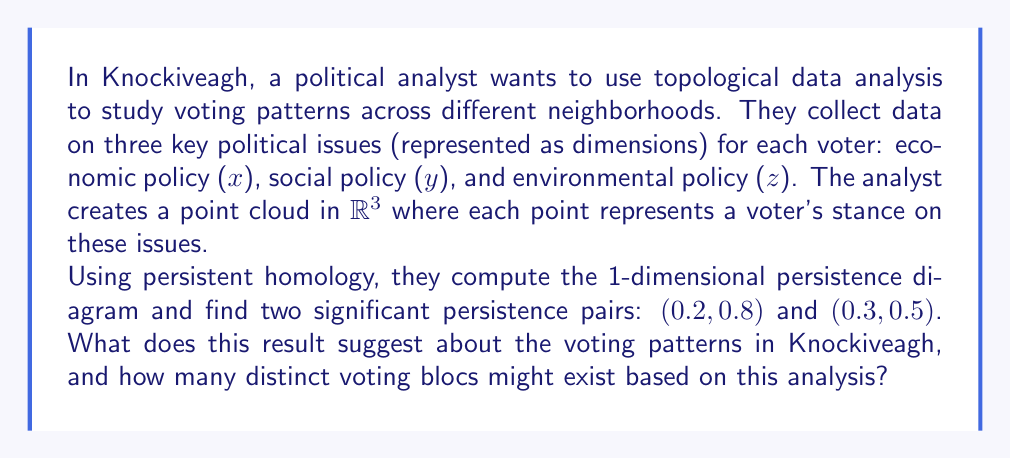What is the answer to this math problem? To interpret this result, we need to understand the concepts of persistent homology and persistence diagrams:

1. Persistent homology is a method in topological data analysis that helps identify topological features (e.g., connected components, loops, voids) in data at different scales.

2. A persistence diagram visualizes these features, with each point $(b, d)$ representing a topological feature that appears at scale $b$ (birth) and disappears at scale $d$ (death).

3. The persistence of a feature is calculated as $d - b$, with larger values indicating more significant features.

In this case, we have two significant 1-dimensional persistence pairs:

a) $(0.2, 0.8)$ with persistence $0.8 - 0.2 = 0.6$
b) $(0.3, 0.5)$ with persistence $0.5 - 0.3 = 0.2$

Interpreting these results:

1. The presence of two significant 1-dimensional features suggests that there are two prominent circular or loop-like structures in the data.

2. In the context of voting patterns, these loops likely represent two distinct voting blocs with similar views that form clusters in the 3-dimensional policy space.

3. The first pair $(0.2, 0.8)$ has higher persistence, indicating a more stable and well-defined voting bloc.

4. The second pair $(0.3, 0.5)$ has lower persistence but is still significant, suggesting a smaller or less cohesive voting bloc.

5. The birth values (0.2 and 0.3) being relatively close suggests that these blocs become apparent at similar scales, indicating they might have comparable internal diversity.

6. The death value of the first pair (0.8) being higher than the second (0.5) suggests that the first bloc maintains its cohesion at larger scales, possibly indicating a broader appeal or more unified stance on the issues.

Based on this analysis, we can infer the existence of at least two distinct voting blocs in Knockiveagh. However, it's important to note that there might be other smaller or less defined groups that are not captured by these two significant persistence pairs.
Answer: The persistence diagram suggests the existence of at least 2 distinct voting blocs in Knockiveagh, with one bloc being more stable and well-defined than the other. 